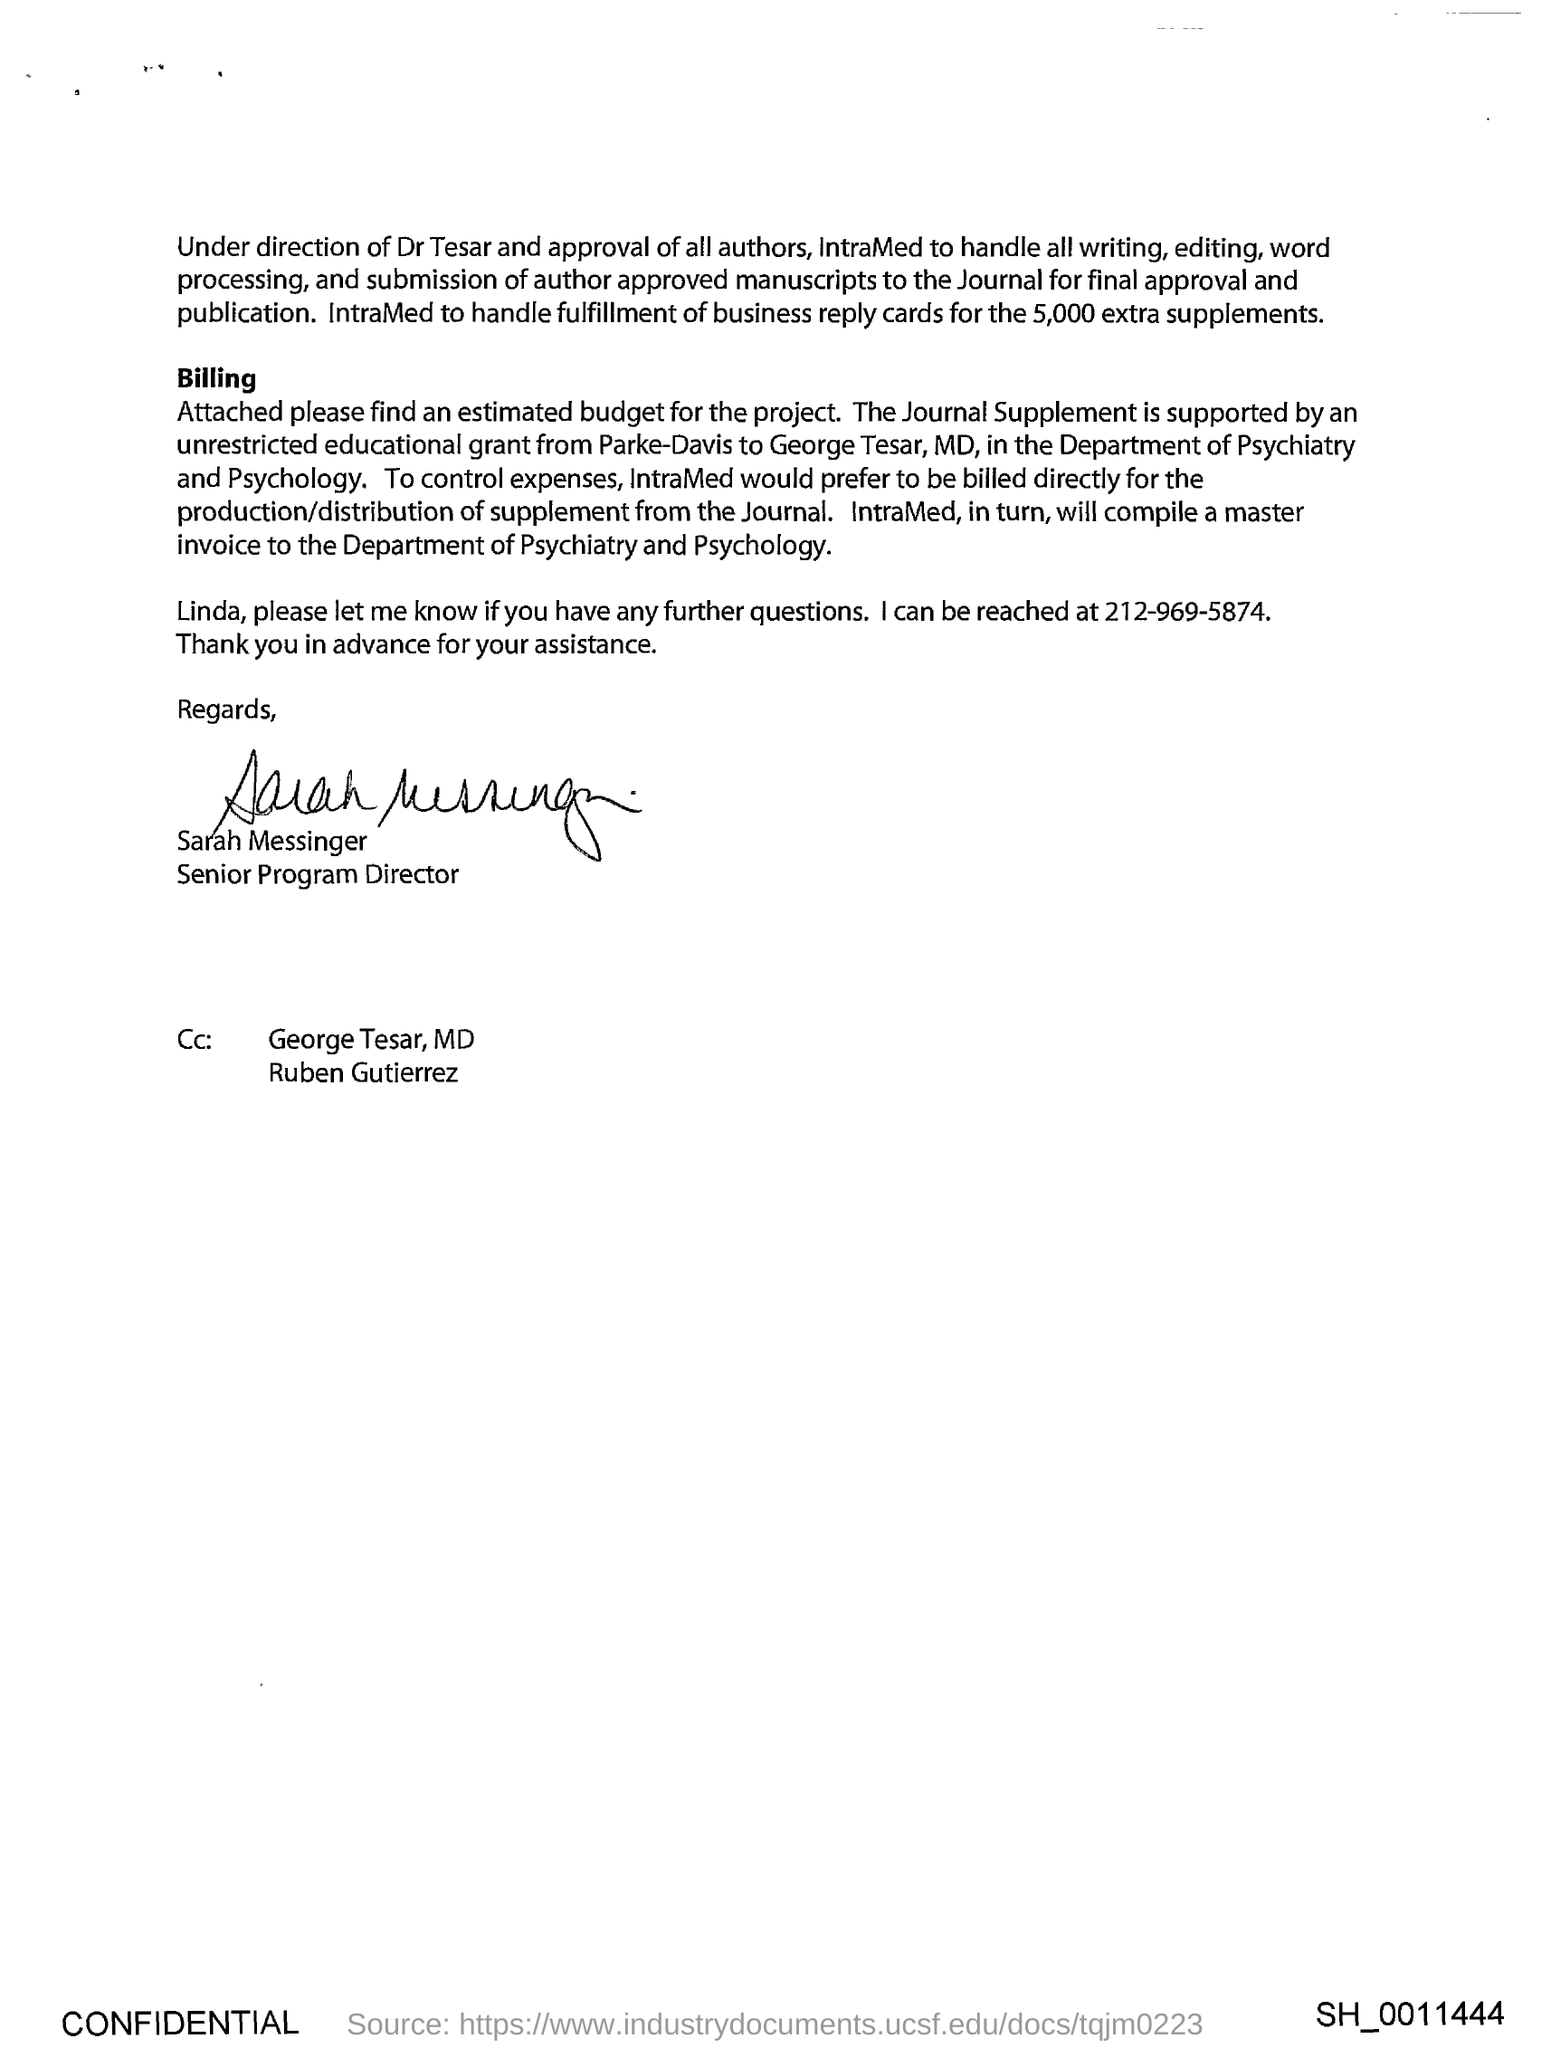Mention a couple of crucial points in this snapshot. The letter is from Sarah Messinger. 